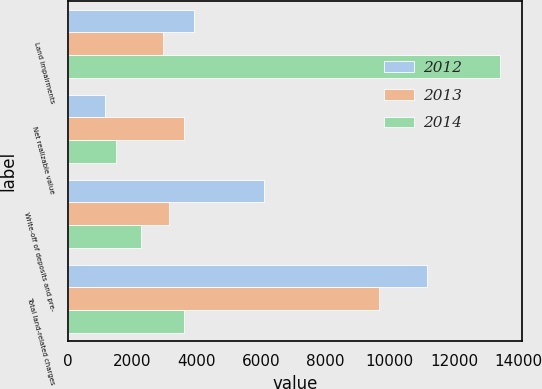Convert chart to OTSL. <chart><loc_0><loc_0><loc_500><loc_500><stacked_bar_chart><ecel><fcel>Land impairments<fcel>Net realizable value<fcel>Write-off of deposits and pre-<fcel>Total land-related charges<nl><fcel>2012<fcel>3911<fcel>1158<fcel>6099<fcel>11168<nl><fcel>2013<fcel>2944<fcel>3606<fcel>3122<fcel>9672<nl><fcel>2014<fcel>13437<fcel>1480<fcel>2278<fcel>3606<nl></chart> 